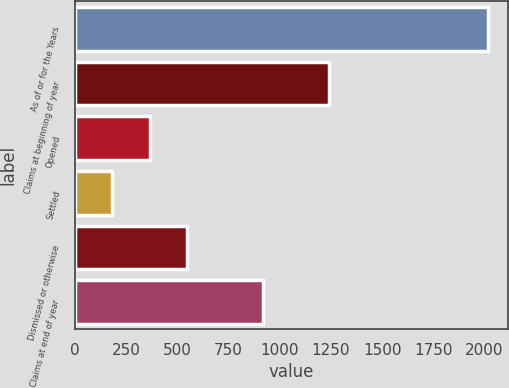<chart> <loc_0><loc_0><loc_500><loc_500><bar_chart><fcel>As of or for the Years<fcel>Claims at beginning of year<fcel>Opened<fcel>Settled<fcel>Dismissed or otherwise<fcel>Claims at end of year<nl><fcel>2015<fcel>1240<fcel>365.3<fcel>182<fcel>548.6<fcel>917<nl></chart> 